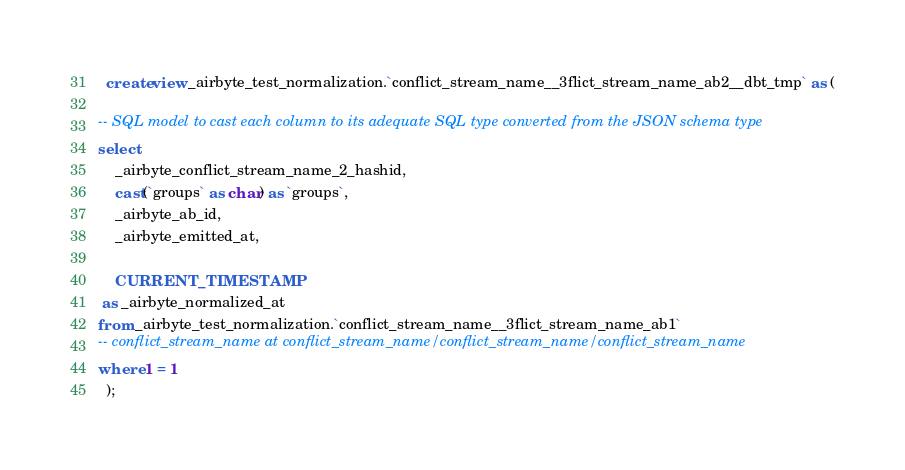<code> <loc_0><loc_0><loc_500><loc_500><_SQL_>
  create view _airbyte_test_normalization.`conflict_stream_name__3flict_stream_name_ab2__dbt_tmp` as (
    
-- SQL model to cast each column to its adequate SQL type converted from the JSON schema type
select
    _airbyte_conflict_stream_name_2_hashid,
    cast(`groups` as char) as `groups`,
    _airbyte_ab_id,
    _airbyte_emitted_at,
    
    CURRENT_TIMESTAMP
 as _airbyte_normalized_at
from _airbyte_test_normalization.`conflict_stream_name__3flict_stream_name_ab1`
-- conflict_stream_name at conflict_stream_name/conflict_stream_name/conflict_stream_name
where 1 = 1
  );
</code> 